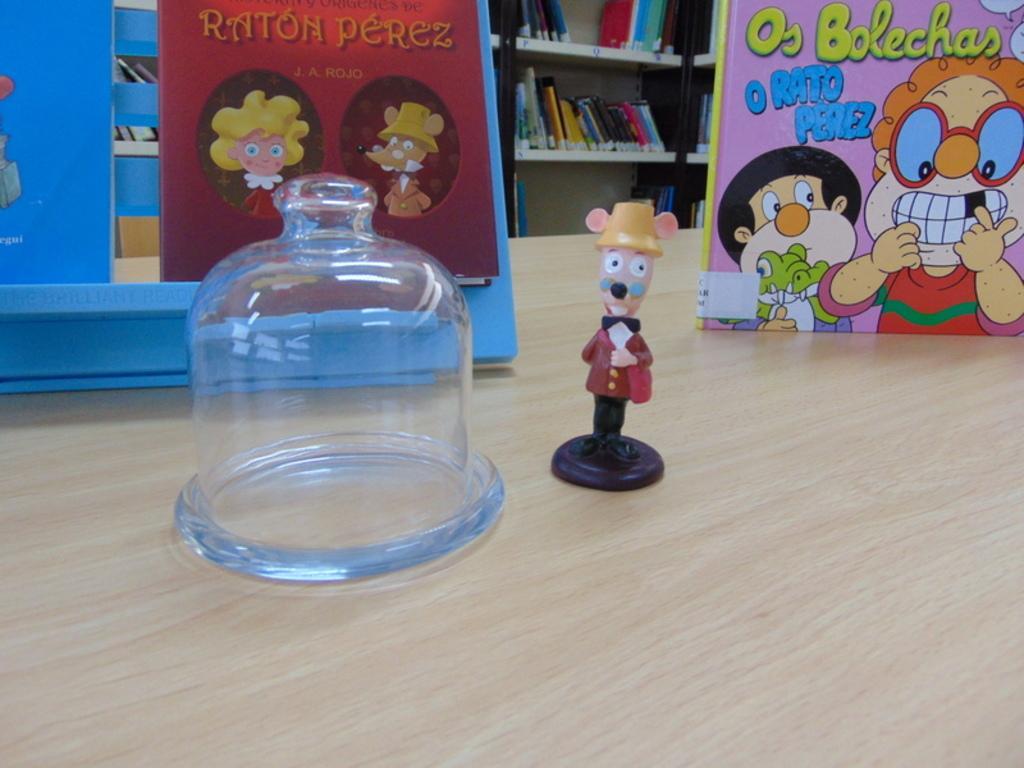Could you give a brief overview of what you see in this image? In this image i can see a toy, a board on a table and at the background i can see few books on a rack. 